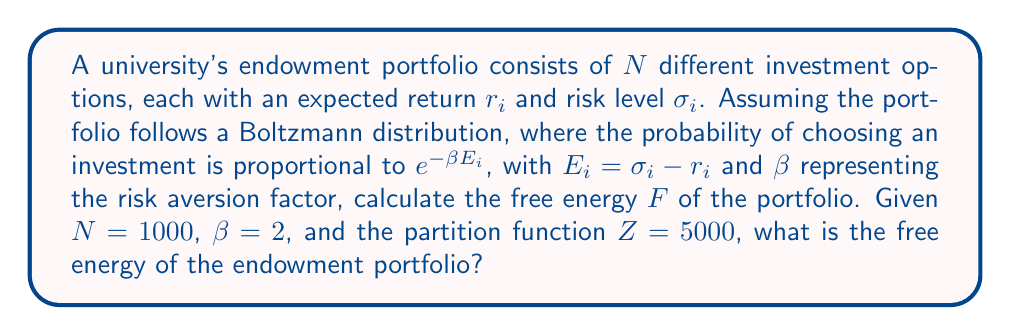Teach me how to tackle this problem. To calculate the free energy of the university's endowment portfolio using statistical mechanics concepts, we'll follow these steps:

1. Recall the formula for free energy in statistical mechanics:
   $$F = -\frac{1}{\beta} \ln Z$$
   Where $F$ is the free energy, $\beta$ is the inverse temperature (in this case, the risk aversion factor), and $Z$ is the partition function.

2. We are given:
   - $\beta = 2$ (risk aversion factor)
   - $Z = 5000$ (partition function)

3. Substitute these values into the free energy formula:
   $$F = -\frac{1}{2} \ln 5000$$

4. Simplify:
   $$F = -0.5 \ln 5000$$

5. Calculate the natural logarithm:
   $$F = -0.5 \times 8.51719319141$$

6. Compute the final result:
   $$F = -4.25859659571$$

The free energy represents the available energy in the system that can be converted to work. In the context of the endowment portfolio, a lower free energy indicates a more stable and efficient allocation of investments.
Answer: $-4.26$ (rounded to two decimal places) 